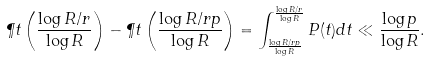Convert formula to latex. <formula><loc_0><loc_0><loc_500><loc_500>\P t \left ( \frac { \log R / r } { \log R } \right ) - \P t \left ( \frac { \log R / r p } { \log R } \right ) = \int _ { \frac { \log R / r p } { \log R } } ^ { \frac { \log R / r } { \log R } } P ( t ) d t \ll \frac { \log p } { \log R } .</formula> 